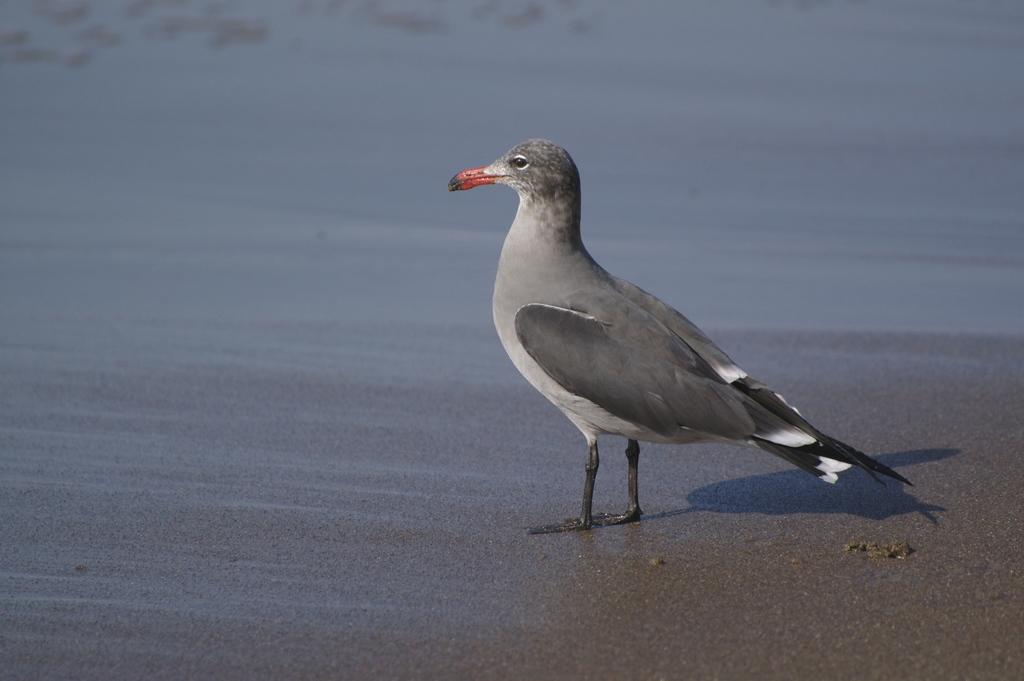What type of animal can be seen in the image? There is a bird in the image. What type of rock is the bird sitting on in the image? There is no rock present in the image; the bird is not sitting on anything. What sound does the bird make in the image? The image is silent, so it is not possible to determine the sound the bird makes. 